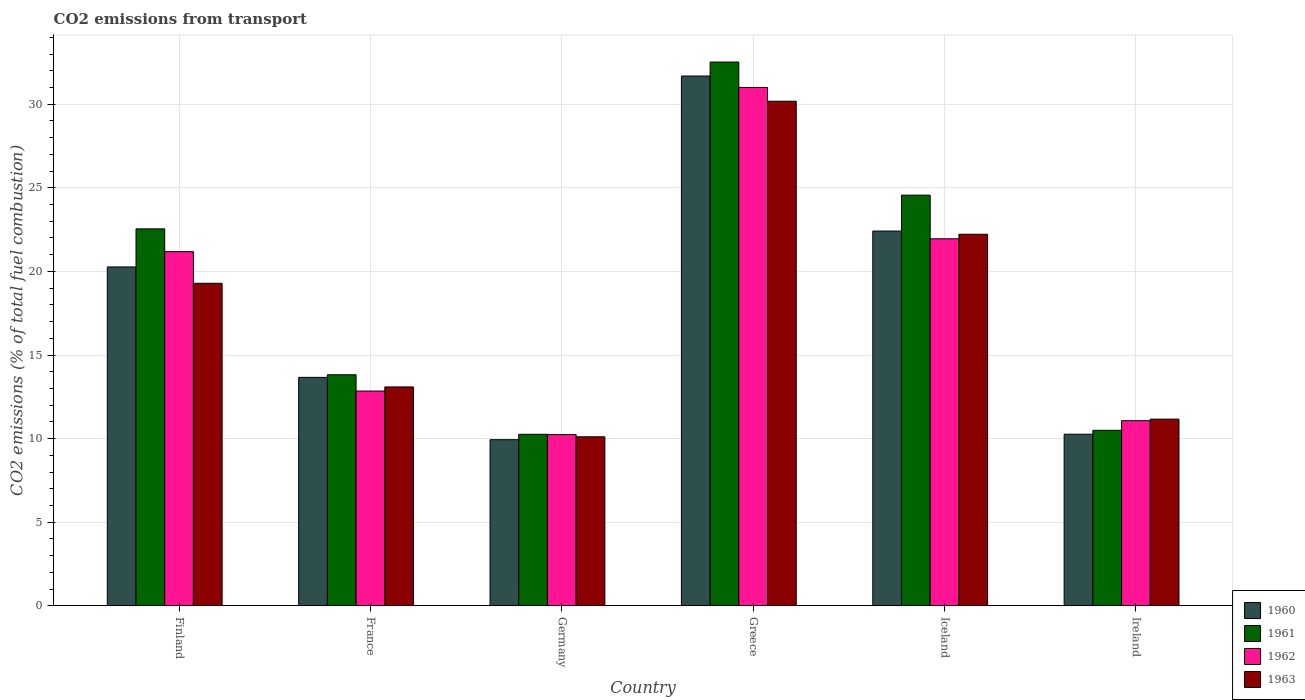How many groups of bars are there?
Keep it short and to the point. 6. What is the label of the 6th group of bars from the left?
Ensure brevity in your answer.  Ireland. What is the total CO2 emitted in 1960 in Finland?
Your answer should be compact. 20.27. Across all countries, what is the maximum total CO2 emitted in 1961?
Offer a very short reply. 32.52. Across all countries, what is the minimum total CO2 emitted in 1963?
Provide a short and direct response. 10.11. What is the total total CO2 emitted in 1961 in the graph?
Keep it short and to the point. 114.2. What is the difference between the total CO2 emitted in 1960 in Iceland and that in Ireland?
Keep it short and to the point. 12.15. What is the difference between the total CO2 emitted in 1962 in Iceland and the total CO2 emitted in 1963 in France?
Your answer should be very brief. 8.86. What is the average total CO2 emitted in 1961 per country?
Provide a succinct answer. 19.03. What is the difference between the total CO2 emitted of/in 1962 and total CO2 emitted of/in 1961 in France?
Offer a very short reply. -0.97. In how many countries, is the total CO2 emitted in 1961 greater than 23?
Make the answer very short. 2. What is the ratio of the total CO2 emitted in 1962 in Finland to that in Ireland?
Make the answer very short. 1.91. What is the difference between the highest and the second highest total CO2 emitted in 1962?
Your answer should be compact. -0.77. What is the difference between the highest and the lowest total CO2 emitted in 1961?
Ensure brevity in your answer.  22.26. In how many countries, is the total CO2 emitted in 1960 greater than the average total CO2 emitted in 1960 taken over all countries?
Your response must be concise. 3. Is it the case that in every country, the sum of the total CO2 emitted in 1960 and total CO2 emitted in 1962 is greater than the sum of total CO2 emitted in 1963 and total CO2 emitted in 1961?
Provide a short and direct response. No. What does the 3rd bar from the left in Greece represents?
Your answer should be very brief. 1962. What does the 3rd bar from the right in Iceland represents?
Your answer should be compact. 1961. How many bars are there?
Ensure brevity in your answer.  24. How many countries are there in the graph?
Provide a succinct answer. 6. Are the values on the major ticks of Y-axis written in scientific E-notation?
Ensure brevity in your answer.  No. Does the graph contain any zero values?
Keep it short and to the point. No. Where does the legend appear in the graph?
Your answer should be very brief. Bottom right. What is the title of the graph?
Make the answer very short. CO2 emissions from transport. Does "1999" appear as one of the legend labels in the graph?
Give a very brief answer. No. What is the label or title of the Y-axis?
Your answer should be compact. CO2 emissions (% of total fuel combustion). What is the CO2 emissions (% of total fuel combustion) in 1960 in Finland?
Give a very brief answer. 20.27. What is the CO2 emissions (% of total fuel combustion) in 1961 in Finland?
Provide a succinct answer. 22.54. What is the CO2 emissions (% of total fuel combustion) in 1962 in Finland?
Your response must be concise. 21.18. What is the CO2 emissions (% of total fuel combustion) in 1963 in Finland?
Ensure brevity in your answer.  19.29. What is the CO2 emissions (% of total fuel combustion) of 1960 in France?
Offer a very short reply. 13.66. What is the CO2 emissions (% of total fuel combustion) in 1961 in France?
Provide a succinct answer. 13.82. What is the CO2 emissions (% of total fuel combustion) of 1962 in France?
Offer a terse response. 12.84. What is the CO2 emissions (% of total fuel combustion) of 1963 in France?
Provide a short and direct response. 13.09. What is the CO2 emissions (% of total fuel combustion) of 1960 in Germany?
Your answer should be compact. 9.93. What is the CO2 emissions (% of total fuel combustion) in 1961 in Germany?
Your answer should be compact. 10.26. What is the CO2 emissions (% of total fuel combustion) of 1962 in Germany?
Your response must be concise. 10.24. What is the CO2 emissions (% of total fuel combustion) of 1963 in Germany?
Your answer should be compact. 10.11. What is the CO2 emissions (% of total fuel combustion) of 1960 in Greece?
Your answer should be very brief. 31.69. What is the CO2 emissions (% of total fuel combustion) in 1961 in Greece?
Your answer should be compact. 32.52. What is the CO2 emissions (% of total fuel combustion) in 1962 in Greece?
Provide a succinct answer. 31. What is the CO2 emissions (% of total fuel combustion) in 1963 in Greece?
Offer a very short reply. 30.18. What is the CO2 emissions (% of total fuel combustion) in 1960 in Iceland?
Your answer should be compact. 22.41. What is the CO2 emissions (% of total fuel combustion) in 1961 in Iceland?
Offer a terse response. 24.56. What is the CO2 emissions (% of total fuel combustion) in 1962 in Iceland?
Offer a terse response. 21.95. What is the CO2 emissions (% of total fuel combustion) of 1963 in Iceland?
Ensure brevity in your answer.  22.22. What is the CO2 emissions (% of total fuel combustion) in 1960 in Ireland?
Offer a very short reply. 10.26. What is the CO2 emissions (% of total fuel combustion) of 1961 in Ireland?
Provide a succinct answer. 10.5. What is the CO2 emissions (% of total fuel combustion) in 1962 in Ireland?
Make the answer very short. 11.07. What is the CO2 emissions (% of total fuel combustion) of 1963 in Ireland?
Your answer should be compact. 11.17. Across all countries, what is the maximum CO2 emissions (% of total fuel combustion) in 1960?
Provide a short and direct response. 31.69. Across all countries, what is the maximum CO2 emissions (% of total fuel combustion) in 1961?
Your answer should be very brief. 32.52. Across all countries, what is the maximum CO2 emissions (% of total fuel combustion) in 1962?
Your response must be concise. 31. Across all countries, what is the maximum CO2 emissions (% of total fuel combustion) of 1963?
Ensure brevity in your answer.  30.18. Across all countries, what is the minimum CO2 emissions (% of total fuel combustion) of 1960?
Ensure brevity in your answer.  9.93. Across all countries, what is the minimum CO2 emissions (% of total fuel combustion) in 1961?
Provide a succinct answer. 10.26. Across all countries, what is the minimum CO2 emissions (% of total fuel combustion) of 1962?
Your response must be concise. 10.24. Across all countries, what is the minimum CO2 emissions (% of total fuel combustion) of 1963?
Provide a short and direct response. 10.11. What is the total CO2 emissions (% of total fuel combustion) in 1960 in the graph?
Your answer should be very brief. 108.23. What is the total CO2 emissions (% of total fuel combustion) of 1961 in the graph?
Provide a short and direct response. 114.2. What is the total CO2 emissions (% of total fuel combustion) in 1962 in the graph?
Give a very brief answer. 108.29. What is the total CO2 emissions (% of total fuel combustion) in 1963 in the graph?
Your answer should be compact. 106.05. What is the difference between the CO2 emissions (% of total fuel combustion) in 1960 in Finland and that in France?
Give a very brief answer. 6.6. What is the difference between the CO2 emissions (% of total fuel combustion) of 1961 in Finland and that in France?
Give a very brief answer. 8.73. What is the difference between the CO2 emissions (% of total fuel combustion) of 1962 in Finland and that in France?
Provide a succinct answer. 8.34. What is the difference between the CO2 emissions (% of total fuel combustion) in 1963 in Finland and that in France?
Provide a succinct answer. 6.2. What is the difference between the CO2 emissions (% of total fuel combustion) in 1960 in Finland and that in Germany?
Provide a short and direct response. 10.33. What is the difference between the CO2 emissions (% of total fuel combustion) of 1961 in Finland and that in Germany?
Provide a short and direct response. 12.29. What is the difference between the CO2 emissions (% of total fuel combustion) of 1962 in Finland and that in Germany?
Provide a succinct answer. 10.94. What is the difference between the CO2 emissions (% of total fuel combustion) of 1963 in Finland and that in Germany?
Provide a short and direct response. 9.18. What is the difference between the CO2 emissions (% of total fuel combustion) of 1960 in Finland and that in Greece?
Your answer should be compact. -11.42. What is the difference between the CO2 emissions (% of total fuel combustion) in 1961 in Finland and that in Greece?
Your response must be concise. -9.98. What is the difference between the CO2 emissions (% of total fuel combustion) in 1962 in Finland and that in Greece?
Make the answer very short. -9.82. What is the difference between the CO2 emissions (% of total fuel combustion) in 1963 in Finland and that in Greece?
Give a very brief answer. -10.89. What is the difference between the CO2 emissions (% of total fuel combustion) in 1960 in Finland and that in Iceland?
Keep it short and to the point. -2.15. What is the difference between the CO2 emissions (% of total fuel combustion) in 1961 in Finland and that in Iceland?
Ensure brevity in your answer.  -2.02. What is the difference between the CO2 emissions (% of total fuel combustion) of 1962 in Finland and that in Iceland?
Your answer should be very brief. -0.77. What is the difference between the CO2 emissions (% of total fuel combustion) in 1963 in Finland and that in Iceland?
Offer a terse response. -2.93. What is the difference between the CO2 emissions (% of total fuel combustion) in 1960 in Finland and that in Ireland?
Ensure brevity in your answer.  10.01. What is the difference between the CO2 emissions (% of total fuel combustion) in 1961 in Finland and that in Ireland?
Provide a short and direct response. 12.05. What is the difference between the CO2 emissions (% of total fuel combustion) in 1962 in Finland and that in Ireland?
Your answer should be compact. 10.11. What is the difference between the CO2 emissions (% of total fuel combustion) in 1963 in Finland and that in Ireland?
Your response must be concise. 8.12. What is the difference between the CO2 emissions (% of total fuel combustion) of 1960 in France and that in Germany?
Offer a very short reply. 3.73. What is the difference between the CO2 emissions (% of total fuel combustion) in 1961 in France and that in Germany?
Your answer should be very brief. 3.56. What is the difference between the CO2 emissions (% of total fuel combustion) of 1962 in France and that in Germany?
Your response must be concise. 2.6. What is the difference between the CO2 emissions (% of total fuel combustion) of 1963 in France and that in Germany?
Make the answer very short. 2.98. What is the difference between the CO2 emissions (% of total fuel combustion) of 1960 in France and that in Greece?
Provide a succinct answer. -18.02. What is the difference between the CO2 emissions (% of total fuel combustion) of 1961 in France and that in Greece?
Provide a succinct answer. -18.7. What is the difference between the CO2 emissions (% of total fuel combustion) of 1962 in France and that in Greece?
Offer a terse response. -18.16. What is the difference between the CO2 emissions (% of total fuel combustion) of 1963 in France and that in Greece?
Offer a terse response. -17.09. What is the difference between the CO2 emissions (% of total fuel combustion) in 1960 in France and that in Iceland?
Provide a succinct answer. -8.75. What is the difference between the CO2 emissions (% of total fuel combustion) in 1961 in France and that in Iceland?
Your response must be concise. -10.74. What is the difference between the CO2 emissions (% of total fuel combustion) of 1962 in France and that in Iceland?
Provide a short and direct response. -9.11. What is the difference between the CO2 emissions (% of total fuel combustion) of 1963 in France and that in Iceland?
Give a very brief answer. -9.13. What is the difference between the CO2 emissions (% of total fuel combustion) in 1960 in France and that in Ireland?
Your answer should be compact. 3.4. What is the difference between the CO2 emissions (% of total fuel combustion) in 1961 in France and that in Ireland?
Your answer should be very brief. 3.32. What is the difference between the CO2 emissions (% of total fuel combustion) in 1962 in France and that in Ireland?
Provide a succinct answer. 1.77. What is the difference between the CO2 emissions (% of total fuel combustion) in 1963 in France and that in Ireland?
Your answer should be very brief. 1.93. What is the difference between the CO2 emissions (% of total fuel combustion) of 1960 in Germany and that in Greece?
Offer a terse response. -21.75. What is the difference between the CO2 emissions (% of total fuel combustion) in 1961 in Germany and that in Greece?
Provide a short and direct response. -22.26. What is the difference between the CO2 emissions (% of total fuel combustion) of 1962 in Germany and that in Greece?
Offer a terse response. -20.76. What is the difference between the CO2 emissions (% of total fuel combustion) in 1963 in Germany and that in Greece?
Provide a short and direct response. -20.07. What is the difference between the CO2 emissions (% of total fuel combustion) in 1960 in Germany and that in Iceland?
Ensure brevity in your answer.  -12.48. What is the difference between the CO2 emissions (% of total fuel combustion) of 1961 in Germany and that in Iceland?
Make the answer very short. -14.3. What is the difference between the CO2 emissions (% of total fuel combustion) in 1962 in Germany and that in Iceland?
Make the answer very short. -11.71. What is the difference between the CO2 emissions (% of total fuel combustion) of 1963 in Germany and that in Iceland?
Your answer should be very brief. -12.12. What is the difference between the CO2 emissions (% of total fuel combustion) of 1960 in Germany and that in Ireland?
Offer a very short reply. -0.33. What is the difference between the CO2 emissions (% of total fuel combustion) in 1961 in Germany and that in Ireland?
Make the answer very short. -0.24. What is the difference between the CO2 emissions (% of total fuel combustion) in 1962 in Germany and that in Ireland?
Provide a short and direct response. -0.83. What is the difference between the CO2 emissions (% of total fuel combustion) of 1963 in Germany and that in Ireland?
Give a very brief answer. -1.06. What is the difference between the CO2 emissions (% of total fuel combustion) of 1960 in Greece and that in Iceland?
Keep it short and to the point. 9.27. What is the difference between the CO2 emissions (% of total fuel combustion) in 1961 in Greece and that in Iceland?
Your response must be concise. 7.96. What is the difference between the CO2 emissions (% of total fuel combustion) of 1962 in Greece and that in Iceland?
Offer a very short reply. 9.05. What is the difference between the CO2 emissions (% of total fuel combustion) of 1963 in Greece and that in Iceland?
Offer a terse response. 7.96. What is the difference between the CO2 emissions (% of total fuel combustion) in 1960 in Greece and that in Ireland?
Provide a short and direct response. 21.42. What is the difference between the CO2 emissions (% of total fuel combustion) of 1961 in Greece and that in Ireland?
Ensure brevity in your answer.  22.03. What is the difference between the CO2 emissions (% of total fuel combustion) of 1962 in Greece and that in Ireland?
Your answer should be compact. 19.93. What is the difference between the CO2 emissions (% of total fuel combustion) of 1963 in Greece and that in Ireland?
Keep it short and to the point. 19.01. What is the difference between the CO2 emissions (% of total fuel combustion) of 1960 in Iceland and that in Ireland?
Ensure brevity in your answer.  12.15. What is the difference between the CO2 emissions (% of total fuel combustion) of 1961 in Iceland and that in Ireland?
Your answer should be very brief. 14.07. What is the difference between the CO2 emissions (% of total fuel combustion) of 1962 in Iceland and that in Ireland?
Offer a terse response. 10.88. What is the difference between the CO2 emissions (% of total fuel combustion) of 1963 in Iceland and that in Ireland?
Your answer should be compact. 11.06. What is the difference between the CO2 emissions (% of total fuel combustion) in 1960 in Finland and the CO2 emissions (% of total fuel combustion) in 1961 in France?
Provide a short and direct response. 6.45. What is the difference between the CO2 emissions (% of total fuel combustion) in 1960 in Finland and the CO2 emissions (% of total fuel combustion) in 1962 in France?
Ensure brevity in your answer.  7.42. What is the difference between the CO2 emissions (% of total fuel combustion) of 1960 in Finland and the CO2 emissions (% of total fuel combustion) of 1963 in France?
Provide a succinct answer. 7.18. What is the difference between the CO2 emissions (% of total fuel combustion) in 1961 in Finland and the CO2 emissions (% of total fuel combustion) in 1962 in France?
Your answer should be compact. 9.7. What is the difference between the CO2 emissions (% of total fuel combustion) of 1961 in Finland and the CO2 emissions (% of total fuel combustion) of 1963 in France?
Keep it short and to the point. 9.45. What is the difference between the CO2 emissions (% of total fuel combustion) of 1962 in Finland and the CO2 emissions (% of total fuel combustion) of 1963 in France?
Provide a succinct answer. 8.09. What is the difference between the CO2 emissions (% of total fuel combustion) of 1960 in Finland and the CO2 emissions (% of total fuel combustion) of 1961 in Germany?
Offer a very short reply. 10.01. What is the difference between the CO2 emissions (% of total fuel combustion) of 1960 in Finland and the CO2 emissions (% of total fuel combustion) of 1962 in Germany?
Your answer should be compact. 10.03. What is the difference between the CO2 emissions (% of total fuel combustion) of 1960 in Finland and the CO2 emissions (% of total fuel combustion) of 1963 in Germany?
Offer a very short reply. 10.16. What is the difference between the CO2 emissions (% of total fuel combustion) of 1961 in Finland and the CO2 emissions (% of total fuel combustion) of 1962 in Germany?
Offer a very short reply. 12.3. What is the difference between the CO2 emissions (% of total fuel combustion) in 1961 in Finland and the CO2 emissions (% of total fuel combustion) in 1963 in Germany?
Provide a succinct answer. 12.44. What is the difference between the CO2 emissions (% of total fuel combustion) of 1962 in Finland and the CO2 emissions (% of total fuel combustion) of 1963 in Germany?
Ensure brevity in your answer.  11.07. What is the difference between the CO2 emissions (% of total fuel combustion) of 1960 in Finland and the CO2 emissions (% of total fuel combustion) of 1961 in Greece?
Provide a succinct answer. -12.25. What is the difference between the CO2 emissions (% of total fuel combustion) in 1960 in Finland and the CO2 emissions (% of total fuel combustion) in 1962 in Greece?
Keep it short and to the point. -10.74. What is the difference between the CO2 emissions (% of total fuel combustion) in 1960 in Finland and the CO2 emissions (% of total fuel combustion) in 1963 in Greece?
Your answer should be very brief. -9.91. What is the difference between the CO2 emissions (% of total fuel combustion) of 1961 in Finland and the CO2 emissions (% of total fuel combustion) of 1962 in Greece?
Your answer should be very brief. -8.46. What is the difference between the CO2 emissions (% of total fuel combustion) of 1961 in Finland and the CO2 emissions (% of total fuel combustion) of 1963 in Greece?
Make the answer very short. -7.63. What is the difference between the CO2 emissions (% of total fuel combustion) in 1962 in Finland and the CO2 emissions (% of total fuel combustion) in 1963 in Greece?
Your answer should be very brief. -9. What is the difference between the CO2 emissions (% of total fuel combustion) in 1960 in Finland and the CO2 emissions (% of total fuel combustion) in 1961 in Iceland?
Provide a short and direct response. -4.29. What is the difference between the CO2 emissions (% of total fuel combustion) of 1960 in Finland and the CO2 emissions (% of total fuel combustion) of 1962 in Iceland?
Provide a short and direct response. -1.68. What is the difference between the CO2 emissions (% of total fuel combustion) in 1960 in Finland and the CO2 emissions (% of total fuel combustion) in 1963 in Iceland?
Your answer should be compact. -1.95. What is the difference between the CO2 emissions (% of total fuel combustion) in 1961 in Finland and the CO2 emissions (% of total fuel combustion) in 1962 in Iceland?
Offer a very short reply. 0.59. What is the difference between the CO2 emissions (% of total fuel combustion) in 1961 in Finland and the CO2 emissions (% of total fuel combustion) in 1963 in Iceland?
Offer a terse response. 0.32. What is the difference between the CO2 emissions (% of total fuel combustion) of 1962 in Finland and the CO2 emissions (% of total fuel combustion) of 1963 in Iceland?
Provide a succinct answer. -1.04. What is the difference between the CO2 emissions (% of total fuel combustion) in 1960 in Finland and the CO2 emissions (% of total fuel combustion) in 1961 in Ireland?
Make the answer very short. 9.77. What is the difference between the CO2 emissions (% of total fuel combustion) in 1960 in Finland and the CO2 emissions (% of total fuel combustion) in 1962 in Ireland?
Your answer should be compact. 9.2. What is the difference between the CO2 emissions (% of total fuel combustion) of 1960 in Finland and the CO2 emissions (% of total fuel combustion) of 1963 in Ireland?
Keep it short and to the point. 9.1. What is the difference between the CO2 emissions (% of total fuel combustion) in 1961 in Finland and the CO2 emissions (% of total fuel combustion) in 1962 in Ireland?
Ensure brevity in your answer.  11.47. What is the difference between the CO2 emissions (% of total fuel combustion) in 1961 in Finland and the CO2 emissions (% of total fuel combustion) in 1963 in Ireland?
Provide a succinct answer. 11.38. What is the difference between the CO2 emissions (% of total fuel combustion) in 1962 in Finland and the CO2 emissions (% of total fuel combustion) in 1963 in Ireland?
Give a very brief answer. 10.02. What is the difference between the CO2 emissions (% of total fuel combustion) of 1960 in France and the CO2 emissions (% of total fuel combustion) of 1961 in Germany?
Ensure brevity in your answer.  3.41. What is the difference between the CO2 emissions (% of total fuel combustion) in 1960 in France and the CO2 emissions (% of total fuel combustion) in 1962 in Germany?
Offer a very short reply. 3.42. What is the difference between the CO2 emissions (% of total fuel combustion) of 1960 in France and the CO2 emissions (% of total fuel combustion) of 1963 in Germany?
Ensure brevity in your answer.  3.56. What is the difference between the CO2 emissions (% of total fuel combustion) of 1961 in France and the CO2 emissions (% of total fuel combustion) of 1962 in Germany?
Your response must be concise. 3.58. What is the difference between the CO2 emissions (% of total fuel combustion) in 1961 in France and the CO2 emissions (% of total fuel combustion) in 1963 in Germany?
Provide a short and direct response. 3.71. What is the difference between the CO2 emissions (% of total fuel combustion) in 1962 in France and the CO2 emissions (% of total fuel combustion) in 1963 in Germany?
Provide a short and direct response. 2.74. What is the difference between the CO2 emissions (% of total fuel combustion) in 1960 in France and the CO2 emissions (% of total fuel combustion) in 1961 in Greece?
Ensure brevity in your answer.  -18.86. What is the difference between the CO2 emissions (% of total fuel combustion) of 1960 in France and the CO2 emissions (% of total fuel combustion) of 1962 in Greece?
Offer a very short reply. -17.34. What is the difference between the CO2 emissions (% of total fuel combustion) in 1960 in France and the CO2 emissions (% of total fuel combustion) in 1963 in Greece?
Provide a short and direct response. -16.52. What is the difference between the CO2 emissions (% of total fuel combustion) of 1961 in France and the CO2 emissions (% of total fuel combustion) of 1962 in Greece?
Your answer should be very brief. -17.18. What is the difference between the CO2 emissions (% of total fuel combustion) in 1961 in France and the CO2 emissions (% of total fuel combustion) in 1963 in Greece?
Keep it short and to the point. -16.36. What is the difference between the CO2 emissions (% of total fuel combustion) in 1962 in France and the CO2 emissions (% of total fuel combustion) in 1963 in Greece?
Provide a succinct answer. -17.33. What is the difference between the CO2 emissions (% of total fuel combustion) of 1960 in France and the CO2 emissions (% of total fuel combustion) of 1961 in Iceland?
Provide a short and direct response. -10.9. What is the difference between the CO2 emissions (% of total fuel combustion) in 1960 in France and the CO2 emissions (% of total fuel combustion) in 1962 in Iceland?
Offer a terse response. -8.29. What is the difference between the CO2 emissions (% of total fuel combustion) of 1960 in France and the CO2 emissions (% of total fuel combustion) of 1963 in Iceland?
Keep it short and to the point. -8.56. What is the difference between the CO2 emissions (% of total fuel combustion) in 1961 in France and the CO2 emissions (% of total fuel combustion) in 1962 in Iceland?
Your answer should be very brief. -8.13. What is the difference between the CO2 emissions (% of total fuel combustion) of 1961 in France and the CO2 emissions (% of total fuel combustion) of 1963 in Iceland?
Provide a short and direct response. -8.4. What is the difference between the CO2 emissions (% of total fuel combustion) of 1962 in France and the CO2 emissions (% of total fuel combustion) of 1963 in Iceland?
Ensure brevity in your answer.  -9.38. What is the difference between the CO2 emissions (% of total fuel combustion) in 1960 in France and the CO2 emissions (% of total fuel combustion) in 1961 in Ireland?
Give a very brief answer. 3.17. What is the difference between the CO2 emissions (% of total fuel combustion) in 1960 in France and the CO2 emissions (% of total fuel combustion) in 1962 in Ireland?
Provide a succinct answer. 2.59. What is the difference between the CO2 emissions (% of total fuel combustion) of 1960 in France and the CO2 emissions (% of total fuel combustion) of 1963 in Ireland?
Provide a short and direct response. 2.5. What is the difference between the CO2 emissions (% of total fuel combustion) in 1961 in France and the CO2 emissions (% of total fuel combustion) in 1962 in Ireland?
Offer a very short reply. 2.75. What is the difference between the CO2 emissions (% of total fuel combustion) of 1961 in France and the CO2 emissions (% of total fuel combustion) of 1963 in Ireland?
Give a very brief answer. 2.65. What is the difference between the CO2 emissions (% of total fuel combustion) of 1962 in France and the CO2 emissions (% of total fuel combustion) of 1963 in Ireland?
Give a very brief answer. 1.68. What is the difference between the CO2 emissions (% of total fuel combustion) in 1960 in Germany and the CO2 emissions (% of total fuel combustion) in 1961 in Greece?
Your answer should be compact. -22.59. What is the difference between the CO2 emissions (% of total fuel combustion) in 1960 in Germany and the CO2 emissions (% of total fuel combustion) in 1962 in Greece?
Give a very brief answer. -21.07. What is the difference between the CO2 emissions (% of total fuel combustion) in 1960 in Germany and the CO2 emissions (% of total fuel combustion) in 1963 in Greece?
Provide a short and direct response. -20.24. What is the difference between the CO2 emissions (% of total fuel combustion) in 1961 in Germany and the CO2 emissions (% of total fuel combustion) in 1962 in Greece?
Provide a short and direct response. -20.75. What is the difference between the CO2 emissions (% of total fuel combustion) in 1961 in Germany and the CO2 emissions (% of total fuel combustion) in 1963 in Greece?
Provide a short and direct response. -19.92. What is the difference between the CO2 emissions (% of total fuel combustion) in 1962 in Germany and the CO2 emissions (% of total fuel combustion) in 1963 in Greece?
Give a very brief answer. -19.94. What is the difference between the CO2 emissions (% of total fuel combustion) in 1960 in Germany and the CO2 emissions (% of total fuel combustion) in 1961 in Iceland?
Keep it short and to the point. -14.63. What is the difference between the CO2 emissions (% of total fuel combustion) in 1960 in Germany and the CO2 emissions (% of total fuel combustion) in 1962 in Iceland?
Offer a terse response. -12.02. What is the difference between the CO2 emissions (% of total fuel combustion) of 1960 in Germany and the CO2 emissions (% of total fuel combustion) of 1963 in Iceland?
Make the answer very short. -12.29. What is the difference between the CO2 emissions (% of total fuel combustion) of 1961 in Germany and the CO2 emissions (% of total fuel combustion) of 1962 in Iceland?
Offer a very short reply. -11.69. What is the difference between the CO2 emissions (% of total fuel combustion) in 1961 in Germany and the CO2 emissions (% of total fuel combustion) in 1963 in Iceland?
Keep it short and to the point. -11.96. What is the difference between the CO2 emissions (% of total fuel combustion) in 1962 in Germany and the CO2 emissions (% of total fuel combustion) in 1963 in Iceland?
Offer a terse response. -11.98. What is the difference between the CO2 emissions (% of total fuel combustion) in 1960 in Germany and the CO2 emissions (% of total fuel combustion) in 1961 in Ireland?
Your response must be concise. -0.56. What is the difference between the CO2 emissions (% of total fuel combustion) of 1960 in Germany and the CO2 emissions (% of total fuel combustion) of 1962 in Ireland?
Ensure brevity in your answer.  -1.14. What is the difference between the CO2 emissions (% of total fuel combustion) of 1960 in Germany and the CO2 emissions (% of total fuel combustion) of 1963 in Ireland?
Offer a very short reply. -1.23. What is the difference between the CO2 emissions (% of total fuel combustion) in 1961 in Germany and the CO2 emissions (% of total fuel combustion) in 1962 in Ireland?
Offer a very short reply. -0.81. What is the difference between the CO2 emissions (% of total fuel combustion) of 1961 in Germany and the CO2 emissions (% of total fuel combustion) of 1963 in Ireland?
Your answer should be very brief. -0.91. What is the difference between the CO2 emissions (% of total fuel combustion) of 1962 in Germany and the CO2 emissions (% of total fuel combustion) of 1963 in Ireland?
Your response must be concise. -0.93. What is the difference between the CO2 emissions (% of total fuel combustion) in 1960 in Greece and the CO2 emissions (% of total fuel combustion) in 1961 in Iceland?
Give a very brief answer. 7.13. What is the difference between the CO2 emissions (% of total fuel combustion) in 1960 in Greece and the CO2 emissions (% of total fuel combustion) in 1962 in Iceland?
Provide a short and direct response. 9.74. What is the difference between the CO2 emissions (% of total fuel combustion) in 1960 in Greece and the CO2 emissions (% of total fuel combustion) in 1963 in Iceland?
Your response must be concise. 9.46. What is the difference between the CO2 emissions (% of total fuel combustion) of 1961 in Greece and the CO2 emissions (% of total fuel combustion) of 1962 in Iceland?
Make the answer very short. 10.57. What is the difference between the CO2 emissions (% of total fuel combustion) in 1961 in Greece and the CO2 emissions (% of total fuel combustion) in 1963 in Iceland?
Your answer should be very brief. 10.3. What is the difference between the CO2 emissions (% of total fuel combustion) in 1962 in Greece and the CO2 emissions (% of total fuel combustion) in 1963 in Iceland?
Your answer should be very brief. 8.78. What is the difference between the CO2 emissions (% of total fuel combustion) in 1960 in Greece and the CO2 emissions (% of total fuel combustion) in 1961 in Ireland?
Offer a terse response. 21.19. What is the difference between the CO2 emissions (% of total fuel combustion) of 1960 in Greece and the CO2 emissions (% of total fuel combustion) of 1962 in Ireland?
Offer a terse response. 20.62. What is the difference between the CO2 emissions (% of total fuel combustion) in 1960 in Greece and the CO2 emissions (% of total fuel combustion) in 1963 in Ireland?
Offer a very short reply. 20.52. What is the difference between the CO2 emissions (% of total fuel combustion) in 1961 in Greece and the CO2 emissions (% of total fuel combustion) in 1962 in Ireland?
Provide a succinct answer. 21.45. What is the difference between the CO2 emissions (% of total fuel combustion) in 1961 in Greece and the CO2 emissions (% of total fuel combustion) in 1963 in Ireland?
Your answer should be very brief. 21.36. What is the difference between the CO2 emissions (% of total fuel combustion) of 1962 in Greece and the CO2 emissions (% of total fuel combustion) of 1963 in Ireland?
Give a very brief answer. 19.84. What is the difference between the CO2 emissions (% of total fuel combustion) of 1960 in Iceland and the CO2 emissions (% of total fuel combustion) of 1961 in Ireland?
Make the answer very short. 11.92. What is the difference between the CO2 emissions (% of total fuel combustion) of 1960 in Iceland and the CO2 emissions (% of total fuel combustion) of 1962 in Ireland?
Give a very brief answer. 11.34. What is the difference between the CO2 emissions (% of total fuel combustion) of 1960 in Iceland and the CO2 emissions (% of total fuel combustion) of 1963 in Ireland?
Offer a terse response. 11.25. What is the difference between the CO2 emissions (% of total fuel combustion) of 1961 in Iceland and the CO2 emissions (% of total fuel combustion) of 1962 in Ireland?
Make the answer very short. 13.49. What is the difference between the CO2 emissions (% of total fuel combustion) in 1961 in Iceland and the CO2 emissions (% of total fuel combustion) in 1963 in Ireland?
Give a very brief answer. 13.4. What is the difference between the CO2 emissions (% of total fuel combustion) in 1962 in Iceland and the CO2 emissions (% of total fuel combustion) in 1963 in Ireland?
Offer a terse response. 10.79. What is the average CO2 emissions (% of total fuel combustion) of 1960 per country?
Make the answer very short. 18.04. What is the average CO2 emissions (% of total fuel combustion) in 1961 per country?
Give a very brief answer. 19.03. What is the average CO2 emissions (% of total fuel combustion) in 1962 per country?
Make the answer very short. 18.05. What is the average CO2 emissions (% of total fuel combustion) in 1963 per country?
Your answer should be compact. 17.68. What is the difference between the CO2 emissions (% of total fuel combustion) of 1960 and CO2 emissions (% of total fuel combustion) of 1961 in Finland?
Your response must be concise. -2.28. What is the difference between the CO2 emissions (% of total fuel combustion) in 1960 and CO2 emissions (% of total fuel combustion) in 1962 in Finland?
Your answer should be very brief. -0.91. What is the difference between the CO2 emissions (% of total fuel combustion) in 1960 and CO2 emissions (% of total fuel combustion) in 1963 in Finland?
Your response must be concise. 0.98. What is the difference between the CO2 emissions (% of total fuel combustion) of 1961 and CO2 emissions (% of total fuel combustion) of 1962 in Finland?
Give a very brief answer. 1.36. What is the difference between the CO2 emissions (% of total fuel combustion) of 1961 and CO2 emissions (% of total fuel combustion) of 1963 in Finland?
Provide a succinct answer. 3.25. What is the difference between the CO2 emissions (% of total fuel combustion) of 1962 and CO2 emissions (% of total fuel combustion) of 1963 in Finland?
Keep it short and to the point. 1.89. What is the difference between the CO2 emissions (% of total fuel combustion) in 1960 and CO2 emissions (% of total fuel combustion) in 1961 in France?
Your response must be concise. -0.16. What is the difference between the CO2 emissions (% of total fuel combustion) in 1960 and CO2 emissions (% of total fuel combustion) in 1962 in France?
Offer a terse response. 0.82. What is the difference between the CO2 emissions (% of total fuel combustion) in 1960 and CO2 emissions (% of total fuel combustion) in 1963 in France?
Provide a succinct answer. 0.57. What is the difference between the CO2 emissions (% of total fuel combustion) in 1961 and CO2 emissions (% of total fuel combustion) in 1962 in France?
Offer a terse response. 0.97. What is the difference between the CO2 emissions (% of total fuel combustion) in 1961 and CO2 emissions (% of total fuel combustion) in 1963 in France?
Ensure brevity in your answer.  0.73. What is the difference between the CO2 emissions (% of total fuel combustion) in 1962 and CO2 emissions (% of total fuel combustion) in 1963 in France?
Your answer should be compact. -0.25. What is the difference between the CO2 emissions (% of total fuel combustion) in 1960 and CO2 emissions (% of total fuel combustion) in 1961 in Germany?
Offer a very short reply. -0.32. What is the difference between the CO2 emissions (% of total fuel combustion) of 1960 and CO2 emissions (% of total fuel combustion) of 1962 in Germany?
Your answer should be compact. -0.3. What is the difference between the CO2 emissions (% of total fuel combustion) in 1960 and CO2 emissions (% of total fuel combustion) in 1963 in Germany?
Your response must be concise. -0.17. What is the difference between the CO2 emissions (% of total fuel combustion) of 1961 and CO2 emissions (% of total fuel combustion) of 1962 in Germany?
Your response must be concise. 0.02. What is the difference between the CO2 emissions (% of total fuel combustion) of 1961 and CO2 emissions (% of total fuel combustion) of 1963 in Germany?
Your response must be concise. 0.15. What is the difference between the CO2 emissions (% of total fuel combustion) in 1962 and CO2 emissions (% of total fuel combustion) in 1963 in Germany?
Keep it short and to the point. 0.13. What is the difference between the CO2 emissions (% of total fuel combustion) of 1960 and CO2 emissions (% of total fuel combustion) of 1961 in Greece?
Your response must be concise. -0.83. What is the difference between the CO2 emissions (% of total fuel combustion) of 1960 and CO2 emissions (% of total fuel combustion) of 1962 in Greece?
Offer a very short reply. 0.68. What is the difference between the CO2 emissions (% of total fuel combustion) of 1960 and CO2 emissions (% of total fuel combustion) of 1963 in Greece?
Your response must be concise. 1.51. What is the difference between the CO2 emissions (% of total fuel combustion) in 1961 and CO2 emissions (% of total fuel combustion) in 1962 in Greece?
Your response must be concise. 1.52. What is the difference between the CO2 emissions (% of total fuel combustion) in 1961 and CO2 emissions (% of total fuel combustion) in 1963 in Greece?
Keep it short and to the point. 2.34. What is the difference between the CO2 emissions (% of total fuel combustion) in 1962 and CO2 emissions (% of total fuel combustion) in 1963 in Greece?
Your response must be concise. 0.82. What is the difference between the CO2 emissions (% of total fuel combustion) of 1960 and CO2 emissions (% of total fuel combustion) of 1961 in Iceland?
Your answer should be very brief. -2.15. What is the difference between the CO2 emissions (% of total fuel combustion) in 1960 and CO2 emissions (% of total fuel combustion) in 1962 in Iceland?
Offer a terse response. 0.46. What is the difference between the CO2 emissions (% of total fuel combustion) of 1960 and CO2 emissions (% of total fuel combustion) of 1963 in Iceland?
Give a very brief answer. 0.19. What is the difference between the CO2 emissions (% of total fuel combustion) of 1961 and CO2 emissions (% of total fuel combustion) of 1962 in Iceland?
Offer a very short reply. 2.61. What is the difference between the CO2 emissions (% of total fuel combustion) in 1961 and CO2 emissions (% of total fuel combustion) in 1963 in Iceland?
Your answer should be very brief. 2.34. What is the difference between the CO2 emissions (% of total fuel combustion) of 1962 and CO2 emissions (% of total fuel combustion) of 1963 in Iceland?
Give a very brief answer. -0.27. What is the difference between the CO2 emissions (% of total fuel combustion) in 1960 and CO2 emissions (% of total fuel combustion) in 1961 in Ireland?
Your answer should be compact. -0.23. What is the difference between the CO2 emissions (% of total fuel combustion) of 1960 and CO2 emissions (% of total fuel combustion) of 1962 in Ireland?
Make the answer very short. -0.81. What is the difference between the CO2 emissions (% of total fuel combustion) of 1960 and CO2 emissions (% of total fuel combustion) of 1963 in Ireland?
Your answer should be very brief. -0.9. What is the difference between the CO2 emissions (% of total fuel combustion) in 1961 and CO2 emissions (% of total fuel combustion) in 1962 in Ireland?
Provide a short and direct response. -0.58. What is the difference between the CO2 emissions (% of total fuel combustion) in 1961 and CO2 emissions (% of total fuel combustion) in 1963 in Ireland?
Keep it short and to the point. -0.67. What is the difference between the CO2 emissions (% of total fuel combustion) in 1962 and CO2 emissions (% of total fuel combustion) in 1963 in Ireland?
Keep it short and to the point. -0.09. What is the ratio of the CO2 emissions (% of total fuel combustion) of 1960 in Finland to that in France?
Give a very brief answer. 1.48. What is the ratio of the CO2 emissions (% of total fuel combustion) in 1961 in Finland to that in France?
Give a very brief answer. 1.63. What is the ratio of the CO2 emissions (% of total fuel combustion) in 1962 in Finland to that in France?
Make the answer very short. 1.65. What is the ratio of the CO2 emissions (% of total fuel combustion) of 1963 in Finland to that in France?
Make the answer very short. 1.47. What is the ratio of the CO2 emissions (% of total fuel combustion) of 1960 in Finland to that in Germany?
Give a very brief answer. 2.04. What is the ratio of the CO2 emissions (% of total fuel combustion) of 1961 in Finland to that in Germany?
Offer a terse response. 2.2. What is the ratio of the CO2 emissions (% of total fuel combustion) in 1962 in Finland to that in Germany?
Give a very brief answer. 2.07. What is the ratio of the CO2 emissions (% of total fuel combustion) of 1963 in Finland to that in Germany?
Your response must be concise. 1.91. What is the ratio of the CO2 emissions (% of total fuel combustion) in 1960 in Finland to that in Greece?
Your response must be concise. 0.64. What is the ratio of the CO2 emissions (% of total fuel combustion) in 1961 in Finland to that in Greece?
Make the answer very short. 0.69. What is the ratio of the CO2 emissions (% of total fuel combustion) in 1962 in Finland to that in Greece?
Your answer should be very brief. 0.68. What is the ratio of the CO2 emissions (% of total fuel combustion) in 1963 in Finland to that in Greece?
Give a very brief answer. 0.64. What is the ratio of the CO2 emissions (% of total fuel combustion) of 1960 in Finland to that in Iceland?
Give a very brief answer. 0.9. What is the ratio of the CO2 emissions (% of total fuel combustion) in 1961 in Finland to that in Iceland?
Offer a terse response. 0.92. What is the ratio of the CO2 emissions (% of total fuel combustion) in 1962 in Finland to that in Iceland?
Offer a terse response. 0.96. What is the ratio of the CO2 emissions (% of total fuel combustion) of 1963 in Finland to that in Iceland?
Offer a very short reply. 0.87. What is the ratio of the CO2 emissions (% of total fuel combustion) in 1960 in Finland to that in Ireland?
Ensure brevity in your answer.  1.97. What is the ratio of the CO2 emissions (% of total fuel combustion) in 1961 in Finland to that in Ireland?
Your answer should be compact. 2.15. What is the ratio of the CO2 emissions (% of total fuel combustion) in 1962 in Finland to that in Ireland?
Your answer should be compact. 1.91. What is the ratio of the CO2 emissions (% of total fuel combustion) of 1963 in Finland to that in Ireland?
Offer a very short reply. 1.73. What is the ratio of the CO2 emissions (% of total fuel combustion) in 1960 in France to that in Germany?
Your answer should be very brief. 1.38. What is the ratio of the CO2 emissions (% of total fuel combustion) in 1961 in France to that in Germany?
Give a very brief answer. 1.35. What is the ratio of the CO2 emissions (% of total fuel combustion) of 1962 in France to that in Germany?
Provide a short and direct response. 1.25. What is the ratio of the CO2 emissions (% of total fuel combustion) of 1963 in France to that in Germany?
Give a very brief answer. 1.3. What is the ratio of the CO2 emissions (% of total fuel combustion) in 1960 in France to that in Greece?
Keep it short and to the point. 0.43. What is the ratio of the CO2 emissions (% of total fuel combustion) in 1961 in France to that in Greece?
Keep it short and to the point. 0.42. What is the ratio of the CO2 emissions (% of total fuel combustion) in 1962 in France to that in Greece?
Your answer should be very brief. 0.41. What is the ratio of the CO2 emissions (% of total fuel combustion) in 1963 in France to that in Greece?
Your answer should be very brief. 0.43. What is the ratio of the CO2 emissions (% of total fuel combustion) in 1960 in France to that in Iceland?
Offer a terse response. 0.61. What is the ratio of the CO2 emissions (% of total fuel combustion) in 1961 in France to that in Iceland?
Your answer should be very brief. 0.56. What is the ratio of the CO2 emissions (% of total fuel combustion) in 1962 in France to that in Iceland?
Keep it short and to the point. 0.59. What is the ratio of the CO2 emissions (% of total fuel combustion) of 1963 in France to that in Iceland?
Offer a very short reply. 0.59. What is the ratio of the CO2 emissions (% of total fuel combustion) in 1960 in France to that in Ireland?
Offer a terse response. 1.33. What is the ratio of the CO2 emissions (% of total fuel combustion) of 1961 in France to that in Ireland?
Keep it short and to the point. 1.32. What is the ratio of the CO2 emissions (% of total fuel combustion) of 1962 in France to that in Ireland?
Ensure brevity in your answer.  1.16. What is the ratio of the CO2 emissions (% of total fuel combustion) in 1963 in France to that in Ireland?
Offer a terse response. 1.17. What is the ratio of the CO2 emissions (% of total fuel combustion) in 1960 in Germany to that in Greece?
Offer a terse response. 0.31. What is the ratio of the CO2 emissions (% of total fuel combustion) of 1961 in Germany to that in Greece?
Give a very brief answer. 0.32. What is the ratio of the CO2 emissions (% of total fuel combustion) in 1962 in Germany to that in Greece?
Ensure brevity in your answer.  0.33. What is the ratio of the CO2 emissions (% of total fuel combustion) of 1963 in Germany to that in Greece?
Your response must be concise. 0.33. What is the ratio of the CO2 emissions (% of total fuel combustion) of 1960 in Germany to that in Iceland?
Your response must be concise. 0.44. What is the ratio of the CO2 emissions (% of total fuel combustion) of 1961 in Germany to that in Iceland?
Make the answer very short. 0.42. What is the ratio of the CO2 emissions (% of total fuel combustion) in 1962 in Germany to that in Iceland?
Ensure brevity in your answer.  0.47. What is the ratio of the CO2 emissions (% of total fuel combustion) of 1963 in Germany to that in Iceland?
Provide a short and direct response. 0.45. What is the ratio of the CO2 emissions (% of total fuel combustion) of 1961 in Germany to that in Ireland?
Make the answer very short. 0.98. What is the ratio of the CO2 emissions (% of total fuel combustion) of 1962 in Germany to that in Ireland?
Offer a very short reply. 0.92. What is the ratio of the CO2 emissions (% of total fuel combustion) in 1963 in Germany to that in Ireland?
Offer a very short reply. 0.91. What is the ratio of the CO2 emissions (% of total fuel combustion) of 1960 in Greece to that in Iceland?
Offer a very short reply. 1.41. What is the ratio of the CO2 emissions (% of total fuel combustion) of 1961 in Greece to that in Iceland?
Offer a very short reply. 1.32. What is the ratio of the CO2 emissions (% of total fuel combustion) in 1962 in Greece to that in Iceland?
Give a very brief answer. 1.41. What is the ratio of the CO2 emissions (% of total fuel combustion) of 1963 in Greece to that in Iceland?
Offer a terse response. 1.36. What is the ratio of the CO2 emissions (% of total fuel combustion) in 1960 in Greece to that in Ireland?
Your answer should be very brief. 3.09. What is the ratio of the CO2 emissions (% of total fuel combustion) of 1961 in Greece to that in Ireland?
Your response must be concise. 3.1. What is the ratio of the CO2 emissions (% of total fuel combustion) in 1962 in Greece to that in Ireland?
Your answer should be compact. 2.8. What is the ratio of the CO2 emissions (% of total fuel combustion) of 1963 in Greece to that in Ireland?
Provide a succinct answer. 2.7. What is the ratio of the CO2 emissions (% of total fuel combustion) in 1960 in Iceland to that in Ireland?
Make the answer very short. 2.18. What is the ratio of the CO2 emissions (% of total fuel combustion) in 1961 in Iceland to that in Ireland?
Make the answer very short. 2.34. What is the ratio of the CO2 emissions (% of total fuel combustion) in 1962 in Iceland to that in Ireland?
Provide a succinct answer. 1.98. What is the ratio of the CO2 emissions (% of total fuel combustion) in 1963 in Iceland to that in Ireland?
Provide a short and direct response. 1.99. What is the difference between the highest and the second highest CO2 emissions (% of total fuel combustion) of 1960?
Your answer should be compact. 9.27. What is the difference between the highest and the second highest CO2 emissions (% of total fuel combustion) in 1961?
Offer a very short reply. 7.96. What is the difference between the highest and the second highest CO2 emissions (% of total fuel combustion) of 1962?
Your response must be concise. 9.05. What is the difference between the highest and the second highest CO2 emissions (% of total fuel combustion) in 1963?
Provide a short and direct response. 7.96. What is the difference between the highest and the lowest CO2 emissions (% of total fuel combustion) of 1960?
Ensure brevity in your answer.  21.75. What is the difference between the highest and the lowest CO2 emissions (% of total fuel combustion) in 1961?
Ensure brevity in your answer.  22.26. What is the difference between the highest and the lowest CO2 emissions (% of total fuel combustion) in 1962?
Your answer should be very brief. 20.76. What is the difference between the highest and the lowest CO2 emissions (% of total fuel combustion) of 1963?
Provide a short and direct response. 20.07. 